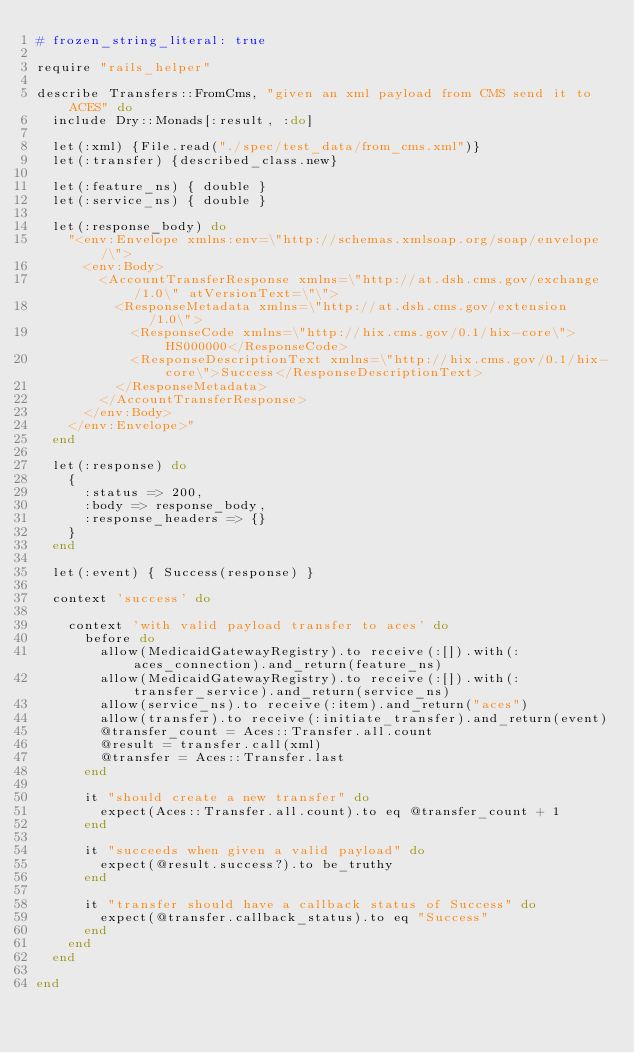<code> <loc_0><loc_0><loc_500><loc_500><_Ruby_># frozen_string_literal: true

require "rails_helper"

describe Transfers::FromCms, "given an xml payload from CMS send it to ACES" do
  include Dry::Monads[:result, :do]

  let(:xml) {File.read("./spec/test_data/from_cms.xml")}
  let(:transfer) {described_class.new}

  let(:feature_ns) { double }
  let(:service_ns) { double }

  let(:response_body) do
    "<env:Envelope xmlns:env=\"http://schemas.xmlsoap.org/soap/envelope/\">
      <env:Body>
        <AccountTransferResponse xmlns=\"http://at.dsh.cms.gov/exchange/1.0\" atVersionText=\"\">
          <ResponseMetadata xmlns=\"http://at.dsh.cms.gov/extension/1.0\">
            <ResponseCode xmlns=\"http://hix.cms.gov/0.1/hix-core\">HS000000</ResponseCode>
            <ResponseDescriptionText xmlns=\"http://hix.cms.gov/0.1/hix-core\">Success</ResponseDescriptionText>
          </ResponseMetadata>
        </AccountTransferResponse>
      </env:Body>
    </env:Envelope>"
  end

  let(:response) do
    {
      :status => 200,
      :body => response_body,
      :response_headers => {}
    }
  end

  let(:event) { Success(response) }

  context 'success' do

    context 'with valid payload transfer to aces' do
      before do
        allow(MedicaidGatewayRegistry).to receive(:[]).with(:aces_connection).and_return(feature_ns)
        allow(MedicaidGatewayRegistry).to receive(:[]).with(:transfer_service).and_return(service_ns)
        allow(service_ns).to receive(:item).and_return("aces")
        allow(transfer).to receive(:initiate_transfer).and_return(event)
        @transfer_count = Aces::Transfer.all.count
        @result = transfer.call(xml)
        @transfer = Aces::Transfer.last
      end

      it "should create a new transfer" do
        expect(Aces::Transfer.all.count).to eq @transfer_count + 1
      end

      it "succeeds when given a valid payload" do
        expect(@result.success?).to be_truthy
      end

      it "transfer should have a callback status of Success" do
        expect(@transfer.callback_status).to eq "Success"
      end
    end
  end

end</code> 